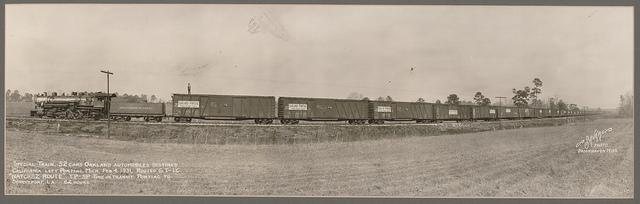How many cars does the train have?
Give a very brief answer. 0. 